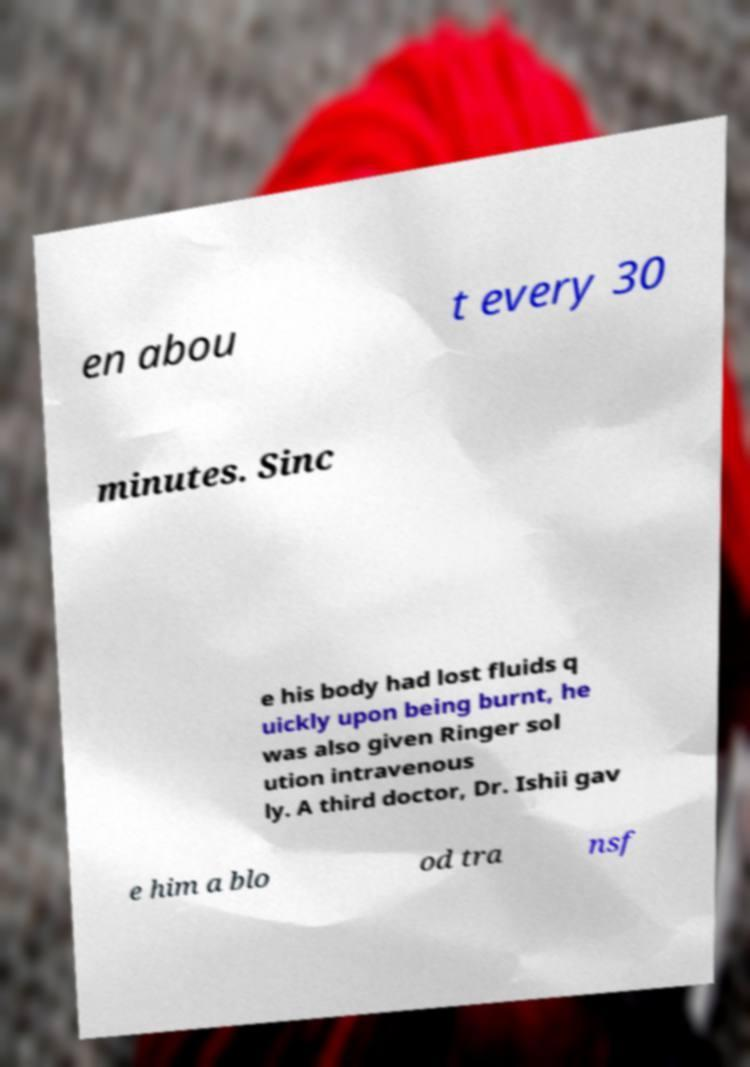There's text embedded in this image that I need extracted. Can you transcribe it verbatim? en abou t every 30 minutes. Sinc e his body had lost fluids q uickly upon being burnt, he was also given Ringer sol ution intravenous ly. A third doctor, Dr. Ishii gav e him a blo od tra nsf 